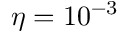Convert formula to latex. <formula><loc_0><loc_0><loc_500><loc_500>\eta = 1 0 ^ { - 3 }</formula> 